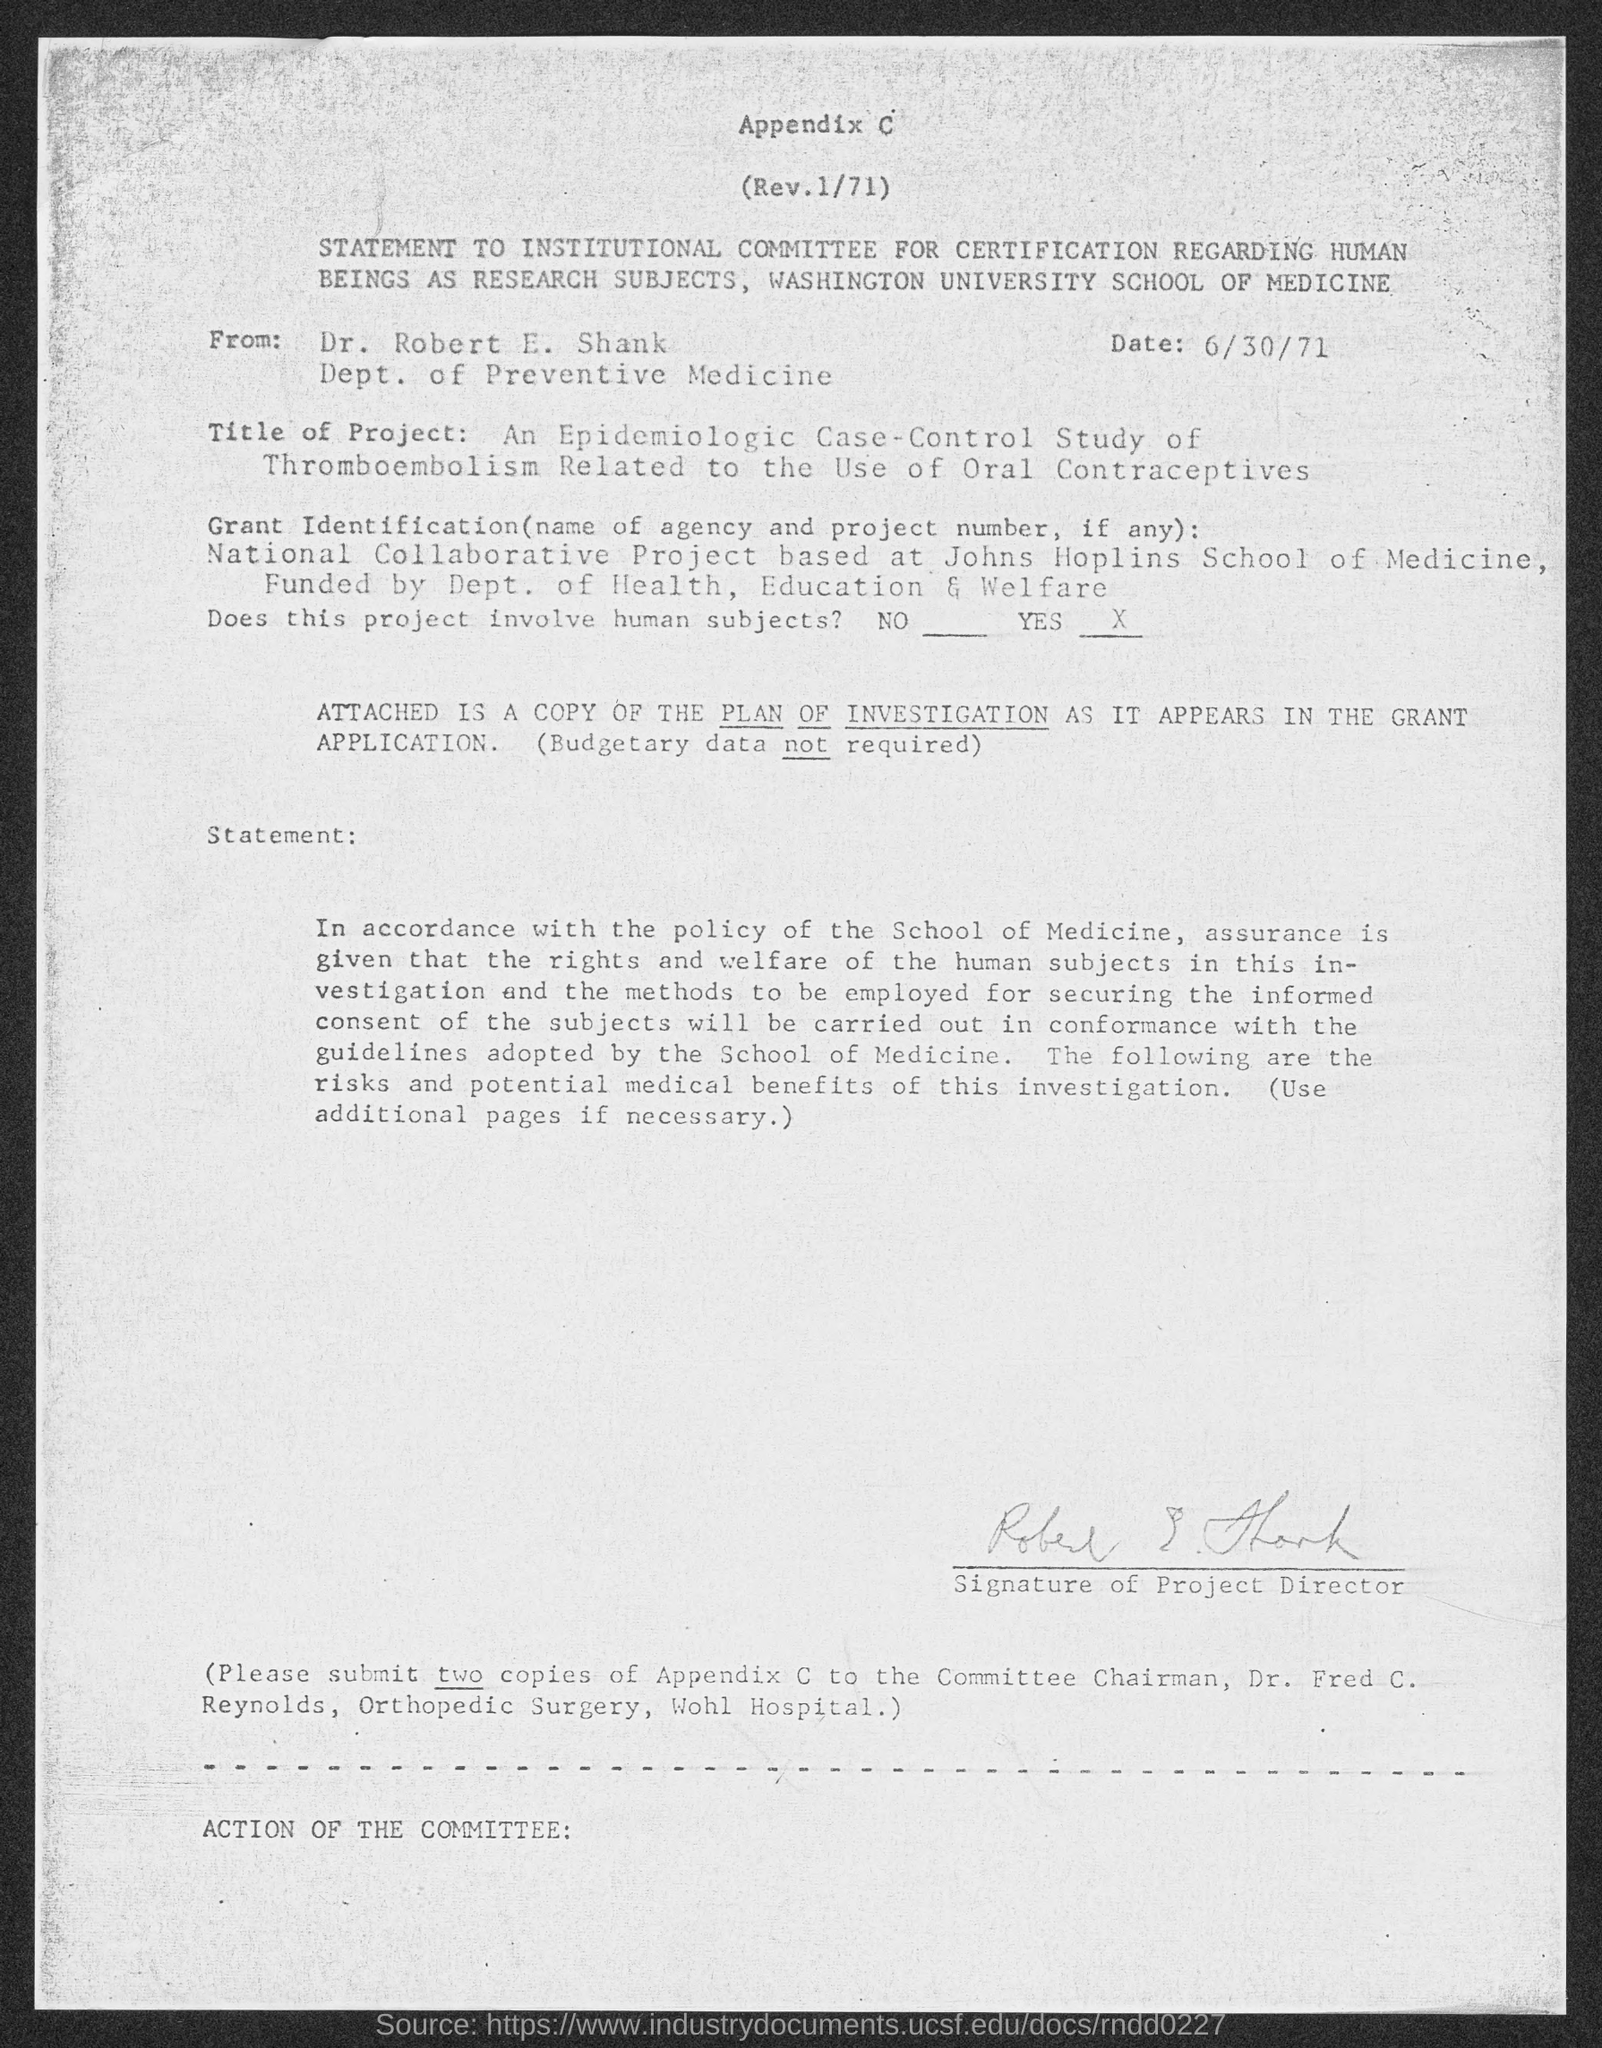Identify some key points in this picture. The letter is from a person named Dr. Robert E. Shank. The date is June 30th, 1971. 